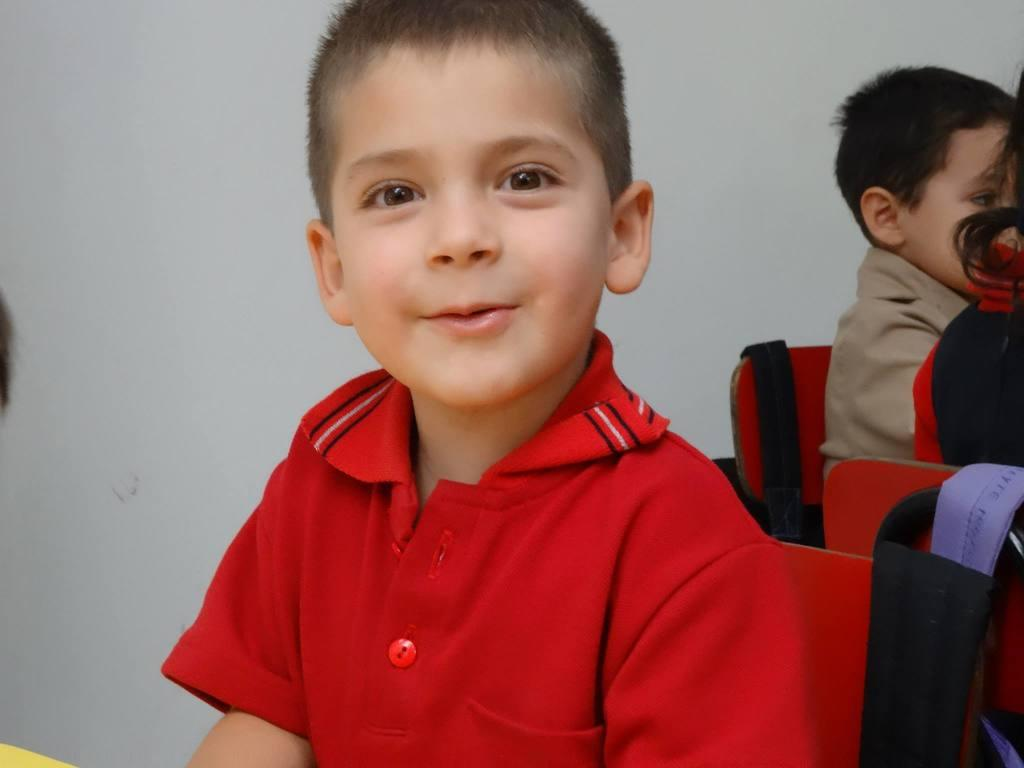What is the boy in the image doing? The boy is sitting and smiling in the image. What is the boy wearing? The boy is wearing a red shirt. How many kids are sitting on chairs on the right side of the image? There are two kids sitting on chairs on the right side of the image. What can be seen in the background of the image? There appears to be a wall in the image. What type of mine is visible in the image? There is no mine present in the image. Does the boy have a sister in the image? The provided facts do not mention the presence of a sister in the image. 